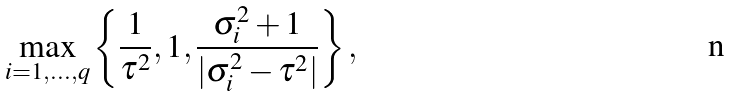<formula> <loc_0><loc_0><loc_500><loc_500>\max _ { i = 1 , \dots , q } \left \{ \frac { 1 } { \tau ^ { 2 } } , 1 , \frac { \sigma _ { i } ^ { 2 } + 1 } { | \sigma _ { i } ^ { 2 } - \tau ^ { 2 } | } \right \} ,</formula> 